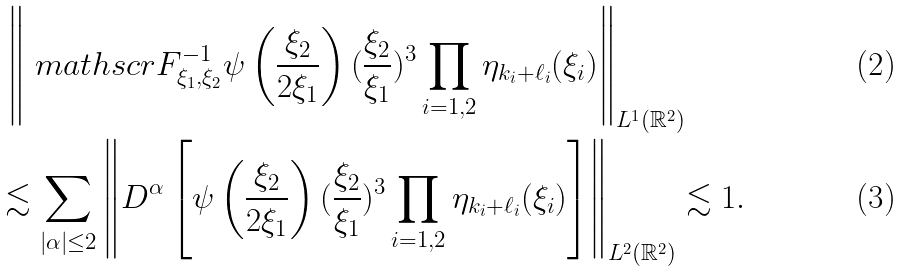<formula> <loc_0><loc_0><loc_500><loc_500>& \, \left \| \ m a t h s c r { F } ^ { - 1 } _ { \xi _ { 1 } , \xi _ { 2 } } \psi \left ( \frac { \xi _ { 2 } } { 2 \xi _ { 1 } } \right ) ( \frac { \xi _ { 2 } } { \xi _ { 1 } } ) ^ { 3 } \prod _ { i = 1 , 2 } \eta _ { k _ { i } + \ell _ { i } } ( \xi _ { i } ) \right \| _ { L ^ { 1 } ( \mathbb { R } ^ { 2 } ) } \\ & \lesssim \sum _ { | \alpha | \leq 2 } \left \| D ^ { \alpha } \left [ \psi \left ( \frac { \xi _ { 2 } } { 2 \xi _ { 1 } } \right ) ( \frac { \xi _ { 2 } } { \xi _ { 1 } } ) ^ { 3 } \prod _ { i = 1 , 2 } \eta _ { k _ { i } + \ell _ { i } } ( \xi _ { i } ) \right ] \right \| _ { L ^ { 2 } ( \mathbb { R } ^ { 2 } ) } \lesssim 1 .</formula> 